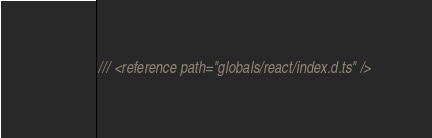Convert code to text. <code><loc_0><loc_0><loc_500><loc_500><_TypeScript_>/// <reference path="globals/react/index.d.ts" />
</code> 